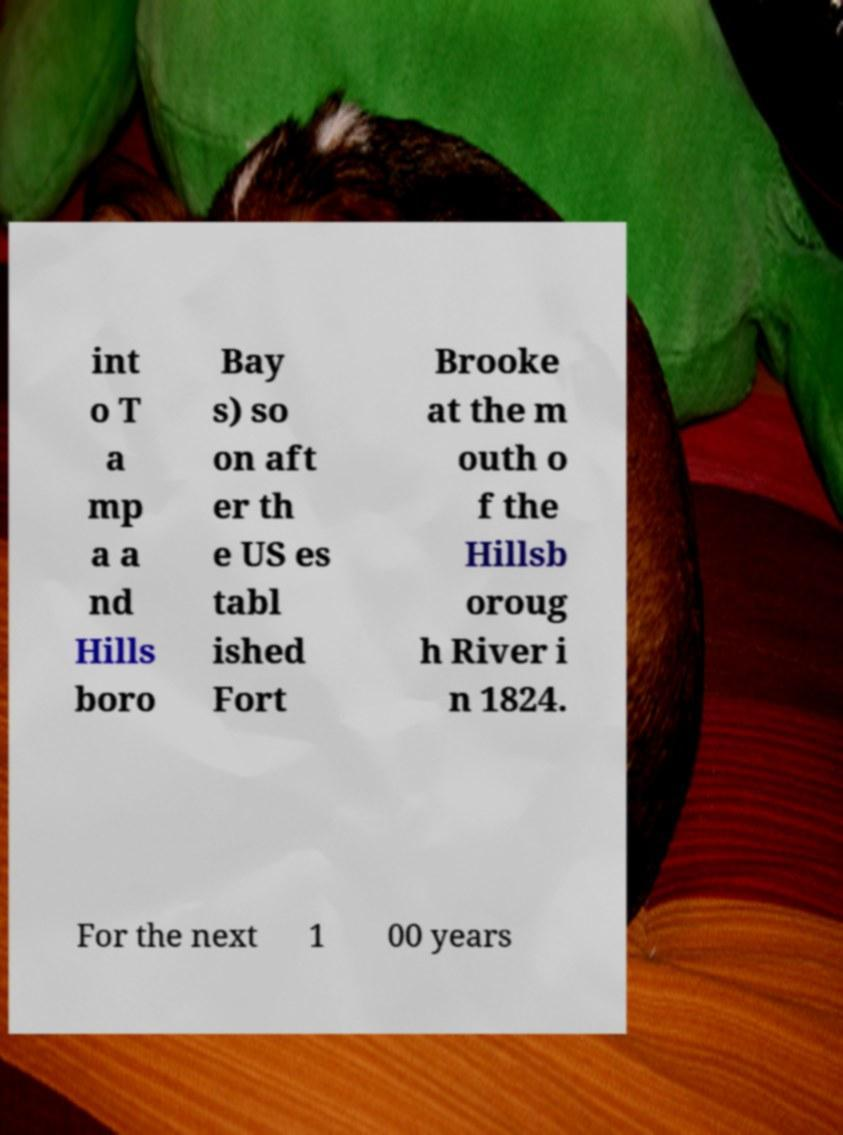Can you read and provide the text displayed in the image?This photo seems to have some interesting text. Can you extract and type it out for me? int o T a mp a a nd Hills boro Bay s) so on aft er th e US es tabl ished Fort Brooke at the m outh o f the Hillsb oroug h River i n 1824. For the next 1 00 years 